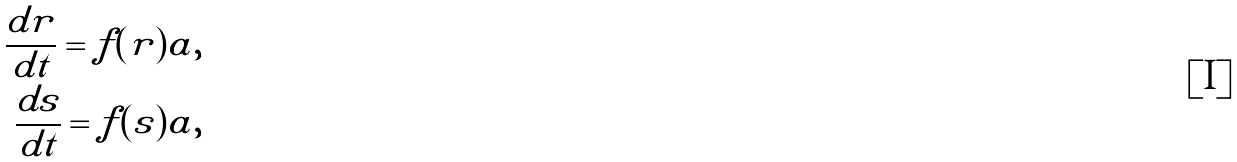<formula> <loc_0><loc_0><loc_500><loc_500>\frac { d r } { d t } = f ( r ) a , \\ \frac { d s } { d t } = f ( s ) a ,</formula> 